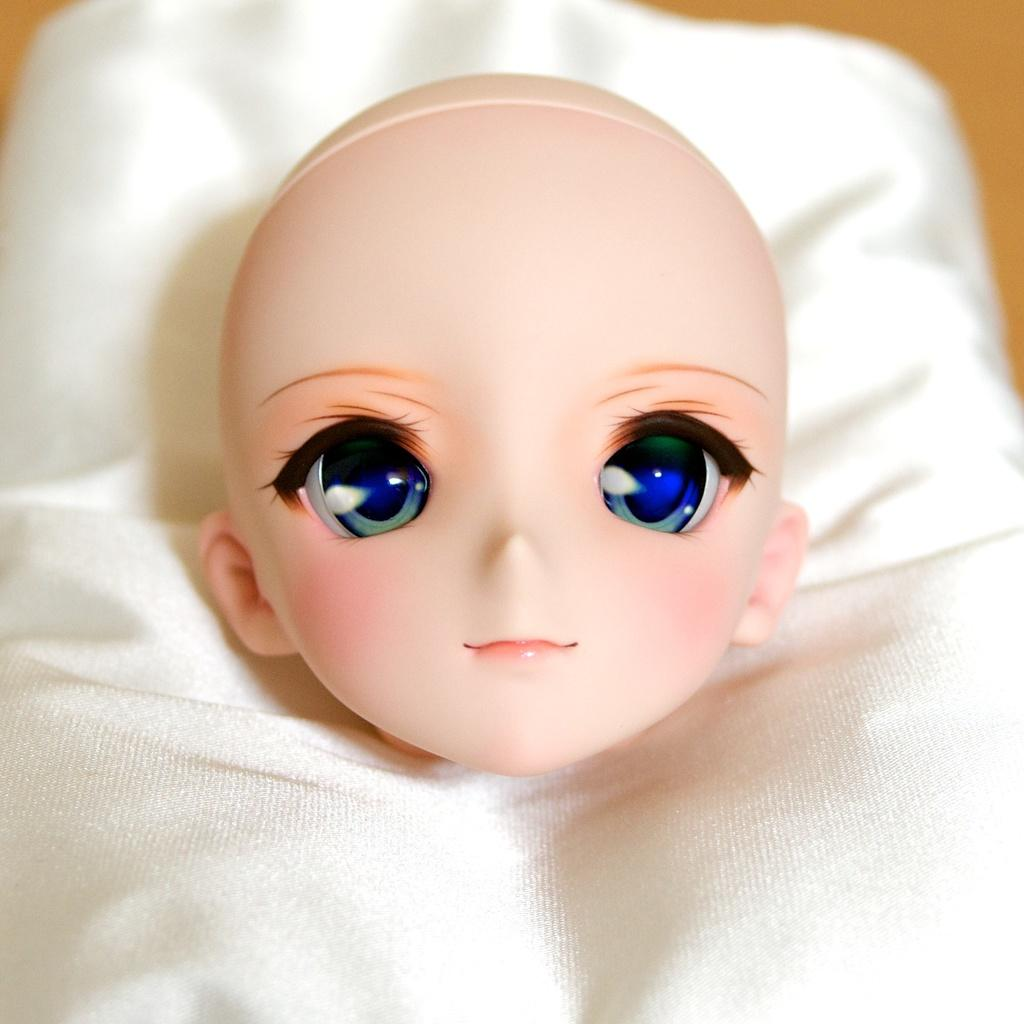What is the main subject of the image? There is a doll in the image. How is the doll positioned in the image? The doll is placed on a cloth. What type of debt is the doll facing in the image? There is no indication of debt in the image; it features a doll placed on a cloth. What color is the crayon that the doll is holding in the image? There is no crayon present in the image; it only shows a doll placed on a cloth. 